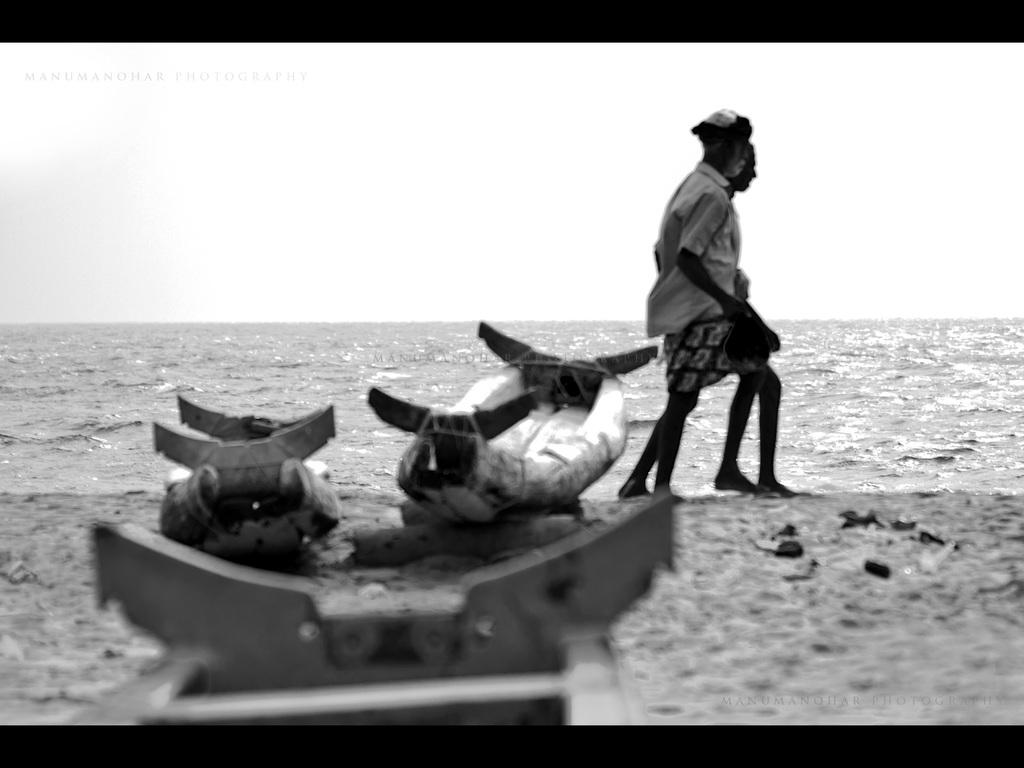Who or what is present in the image? There are people in the image. What objects can be seen at the bottom of the image? There are boats at the bottom of the image. What natural element is visible in the background of the image? There is water visible in the background of the image. What else can be seen in the background of the image? The sky is visible in the background of the image. How many pizzas are being held by the cat in the image? There is no cat or pizza present in the image. 